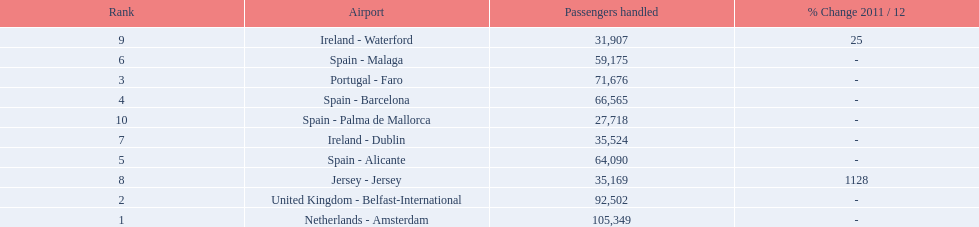What are the names of all the airports? Netherlands - Amsterdam, United Kingdom - Belfast-International, Portugal - Faro, Spain - Barcelona, Spain - Alicante, Spain - Malaga, Ireland - Dublin, Jersey - Jersey, Ireland - Waterford, Spain - Palma de Mallorca. Of these, what are all the passenger counts? 105,349, 92,502, 71,676, 66,565, 64,090, 59,175, 35,524, 35,169, 31,907, 27,718. Of these, which airport had more passengers than the united kingdom? Netherlands - Amsterdam. 